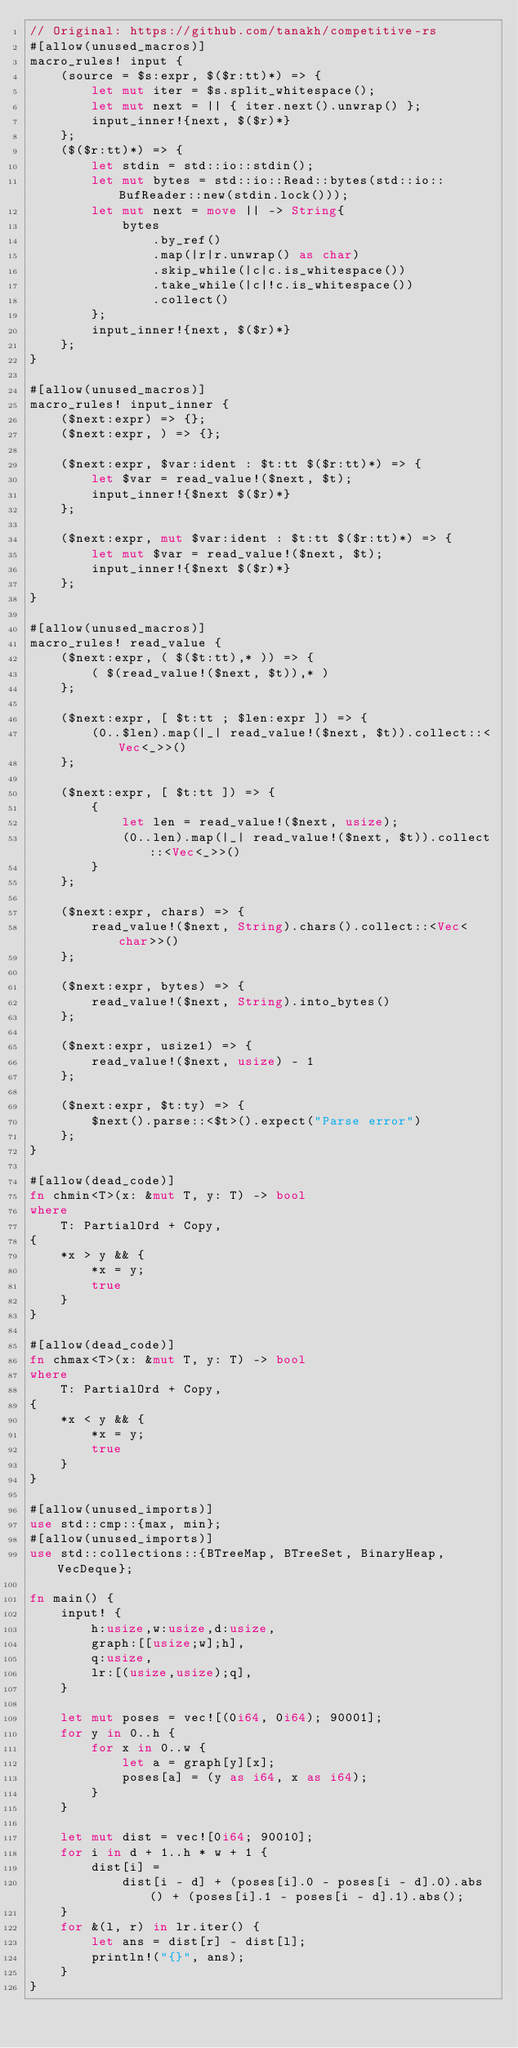Convert code to text. <code><loc_0><loc_0><loc_500><loc_500><_Rust_>// Original: https://github.com/tanakh/competitive-rs
#[allow(unused_macros)]
macro_rules! input {
    (source = $s:expr, $($r:tt)*) => {
        let mut iter = $s.split_whitespace();
        let mut next = || { iter.next().unwrap() };
        input_inner!{next, $($r)*}
    };
    ($($r:tt)*) => {
        let stdin = std::io::stdin();
        let mut bytes = std::io::Read::bytes(std::io::BufReader::new(stdin.lock()));
        let mut next = move || -> String{
            bytes
                .by_ref()
                .map(|r|r.unwrap() as char)
                .skip_while(|c|c.is_whitespace())
                .take_while(|c|!c.is_whitespace())
                .collect()
        };
        input_inner!{next, $($r)*}
    };
}

#[allow(unused_macros)]
macro_rules! input_inner {
    ($next:expr) => {};
    ($next:expr, ) => {};

    ($next:expr, $var:ident : $t:tt $($r:tt)*) => {
        let $var = read_value!($next, $t);
        input_inner!{$next $($r)*}
    };

    ($next:expr, mut $var:ident : $t:tt $($r:tt)*) => {
        let mut $var = read_value!($next, $t);
        input_inner!{$next $($r)*}
    };
}

#[allow(unused_macros)]
macro_rules! read_value {
    ($next:expr, ( $($t:tt),* )) => {
        ( $(read_value!($next, $t)),* )
    };

    ($next:expr, [ $t:tt ; $len:expr ]) => {
        (0..$len).map(|_| read_value!($next, $t)).collect::<Vec<_>>()
    };

    ($next:expr, [ $t:tt ]) => {
        {
            let len = read_value!($next, usize);
            (0..len).map(|_| read_value!($next, $t)).collect::<Vec<_>>()
        }
    };

    ($next:expr, chars) => {
        read_value!($next, String).chars().collect::<Vec<char>>()
    };

    ($next:expr, bytes) => {
        read_value!($next, String).into_bytes()
    };

    ($next:expr, usize1) => {
        read_value!($next, usize) - 1
    };

    ($next:expr, $t:ty) => {
        $next().parse::<$t>().expect("Parse error")
    };
}

#[allow(dead_code)]
fn chmin<T>(x: &mut T, y: T) -> bool
where
    T: PartialOrd + Copy,
{
    *x > y && {
        *x = y;
        true
    }
}

#[allow(dead_code)]
fn chmax<T>(x: &mut T, y: T) -> bool
where
    T: PartialOrd + Copy,
{
    *x < y && {
        *x = y;
        true
    }
}

#[allow(unused_imports)]
use std::cmp::{max, min};
#[allow(unused_imports)]
use std::collections::{BTreeMap, BTreeSet, BinaryHeap, VecDeque};

fn main() {
    input! {
        h:usize,w:usize,d:usize,
        graph:[[usize;w];h],
        q:usize,
        lr:[(usize,usize);q],
    }

    let mut poses = vec![(0i64, 0i64); 90001];
    for y in 0..h {
        for x in 0..w {
            let a = graph[y][x];
            poses[a] = (y as i64, x as i64);
        }
    }

    let mut dist = vec![0i64; 90010];
    for i in d + 1..h * w + 1 {
        dist[i] =
            dist[i - d] + (poses[i].0 - poses[i - d].0).abs() + (poses[i].1 - poses[i - d].1).abs();
    }
    for &(l, r) in lr.iter() {
        let ans = dist[r] - dist[l];
        println!("{}", ans);
    }
}
</code> 